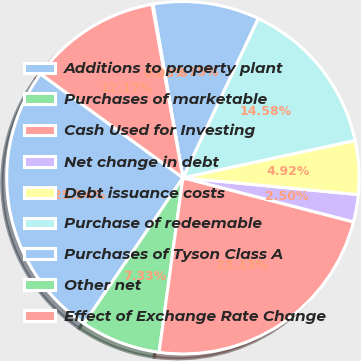Convert chart. <chart><loc_0><loc_0><loc_500><loc_500><pie_chart><fcel>Additions to property plant<fcel>Purchases of marketable<fcel>Cash Used for Investing<fcel>Net change in debt<fcel>Debt issuance costs<fcel>Purchase of redeemable<fcel>Purchases of Tyson Class A<fcel>Other net<fcel>Effect of Exchange Rate Change<nl><fcel>25.54%<fcel>7.33%<fcel>23.13%<fcel>2.5%<fcel>4.92%<fcel>14.58%<fcel>9.75%<fcel>0.08%<fcel>12.17%<nl></chart> 